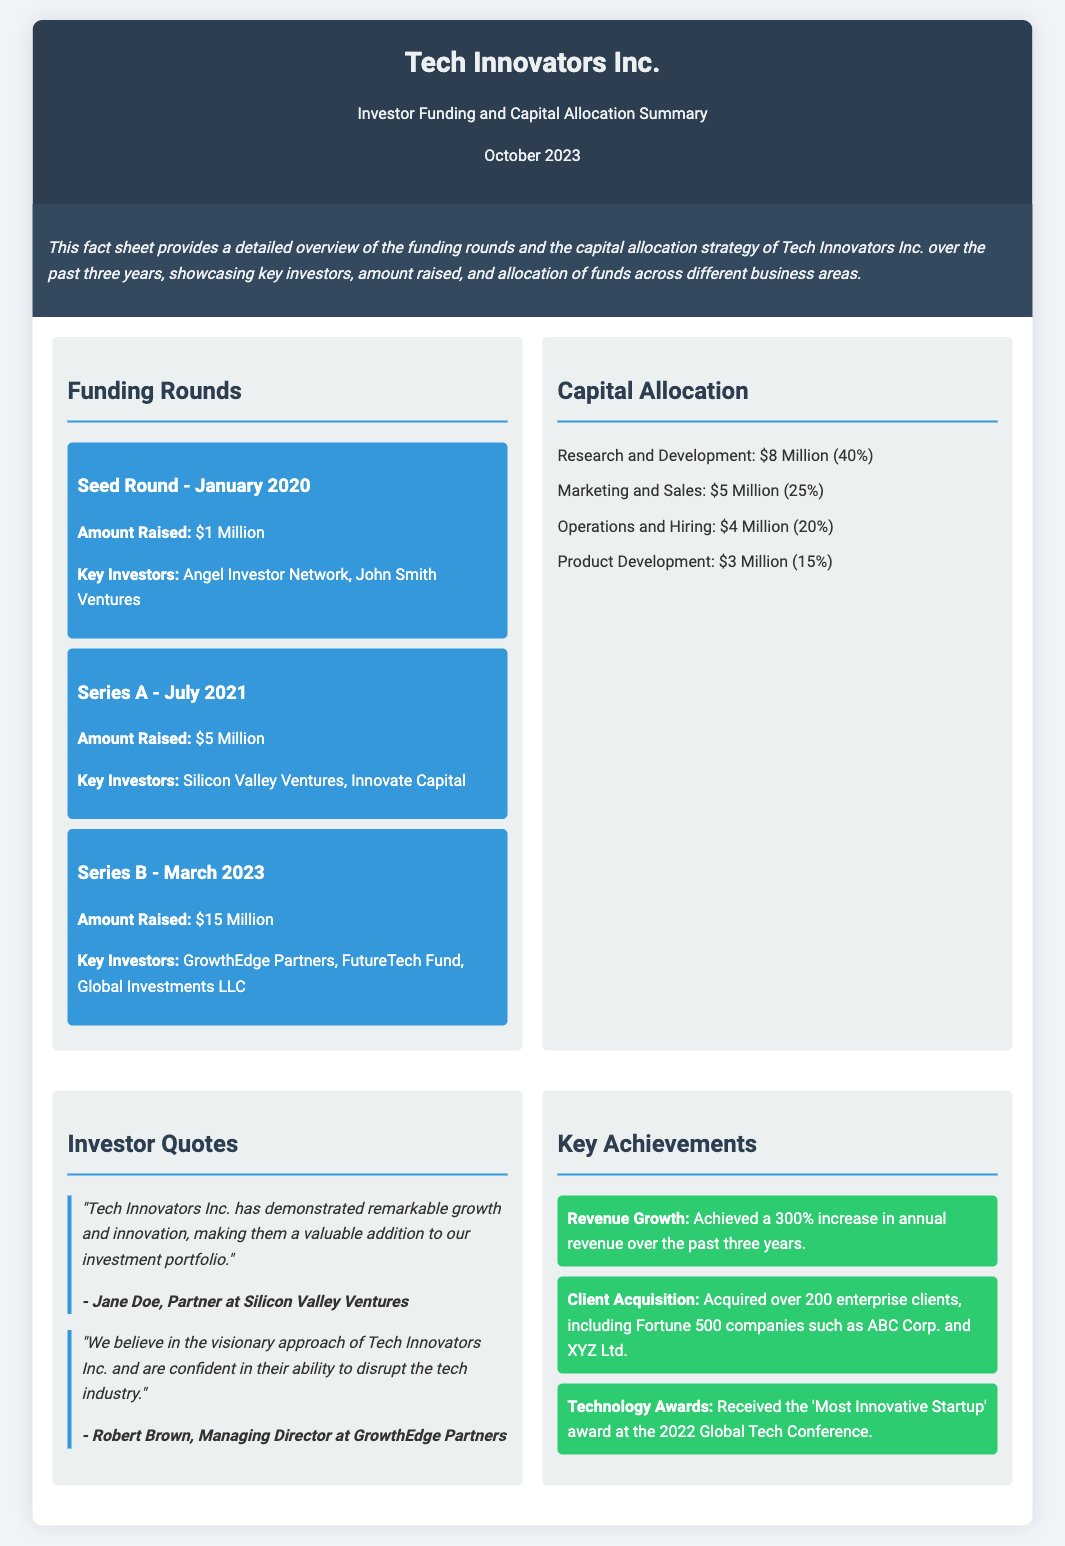What was the amount raised in the Series A funding round? The Series A funding round raised $5 Million.
Answer: $5 Million Who were the key investors in the Seed Round? The Seed Round had key investors including Angel Investor Network and John Smith Ventures.
Answer: Angel Investor Network, John Smith Ventures What percentage of the funds was allocated to Research and Development? Research and Development received 40% of the total funds allocated.
Answer: 40% How many enterprise clients has Tech Innovators Inc. acquired? They have acquired over 200 enterprise clients.
Answer: over 200 Which award did Tech Innovators Inc. receive in 2022? They received the 'Most Innovative Startup' award at the 2022 Global Tech Conference.
Answer: 'Most Innovative Startup' award What is the total amount raised across all funding rounds? The total raised is $1 Million (Seed) + $5 Million (Series A) + $15 Million (Series B) = $21 Million.
Answer: $21 Million What is the primary focus of the capital allocation? The primary focus is on Research and Development, which received the largest share of funds.
Answer: Research and Development Who expressed confidence in Tech Innovators Inc.'s ability to disrupt the tech industry? Robert Brown, Managing Director at GrowthEdge Partners, expressed this confidence.
Answer: Robert Brown What is the total percentage allocated to Marketing and Sales? The total percentage allocated to Marketing and Sales is 25%.
Answer: 25% 